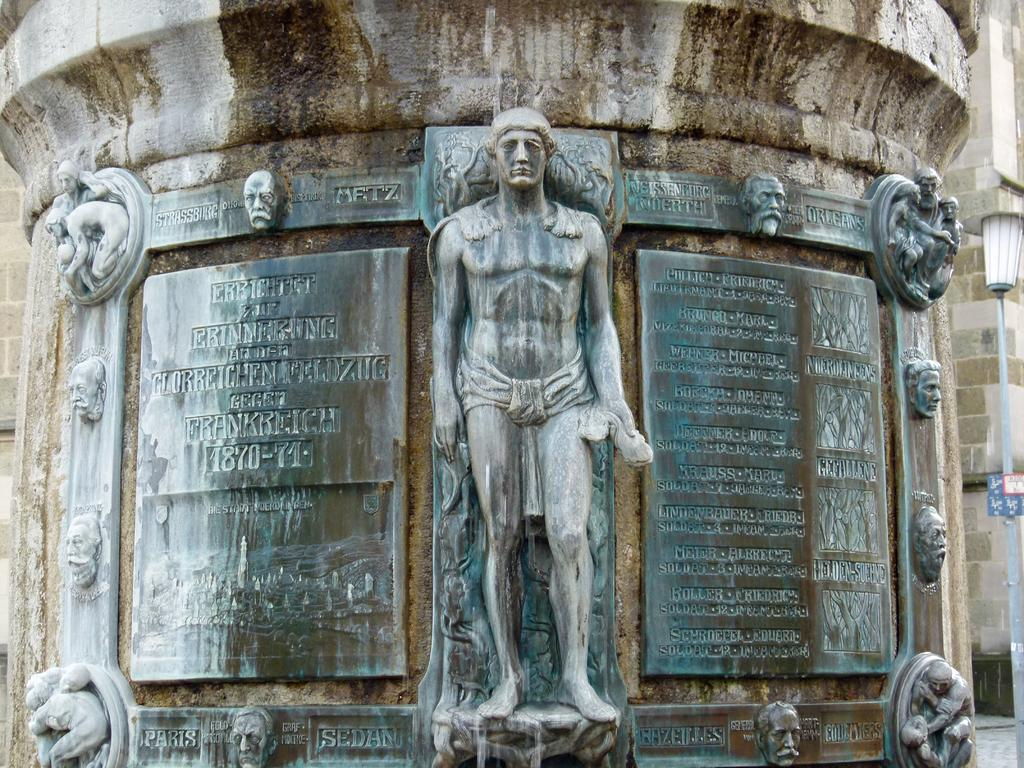What type of artwork is featured in the image? There are sculptures in the image. How are the sculptures positioned in the image? The sculptures are attached to a tank. Can you describe the variety of sculptures in the image? There are different sculptures in the image. What additional information is provided about the sculptures? Descriptions of the sculptures are present beside them. What type of sheet is covering the sculptures in the image? There is no sheet covering the sculptures in the image; they are attached to a tank. 